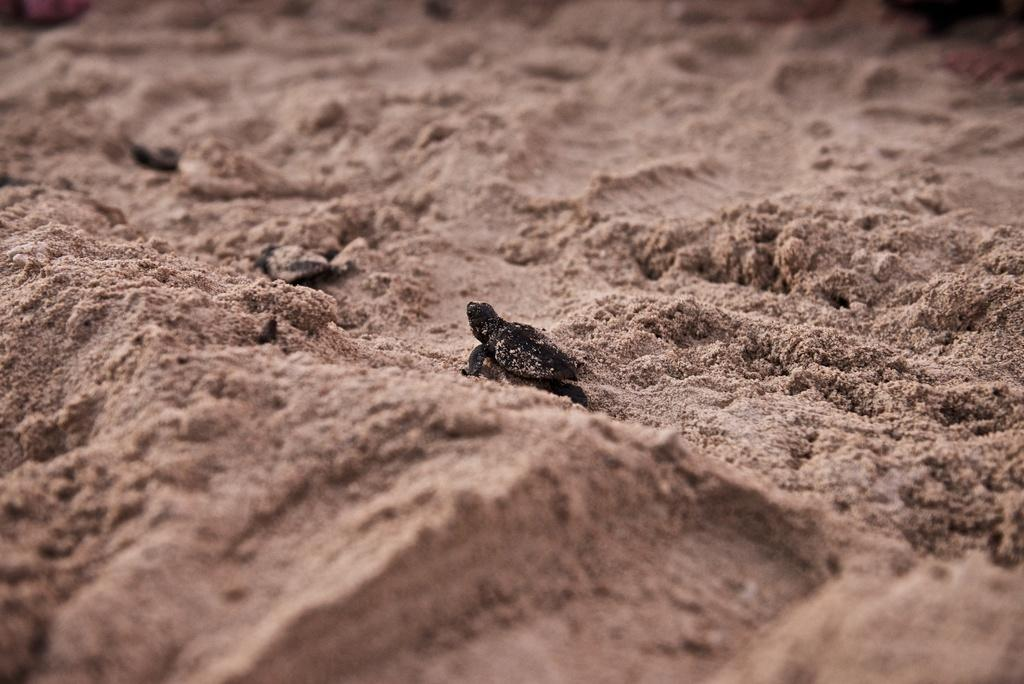What type of animals are present in the image? There are turtles in the image. Where are the turtles located? The turtles are on the sand. What team of men is pulling the carriage in the image? There is no team of men or carriage present in the image; it features turtles on the sand. 